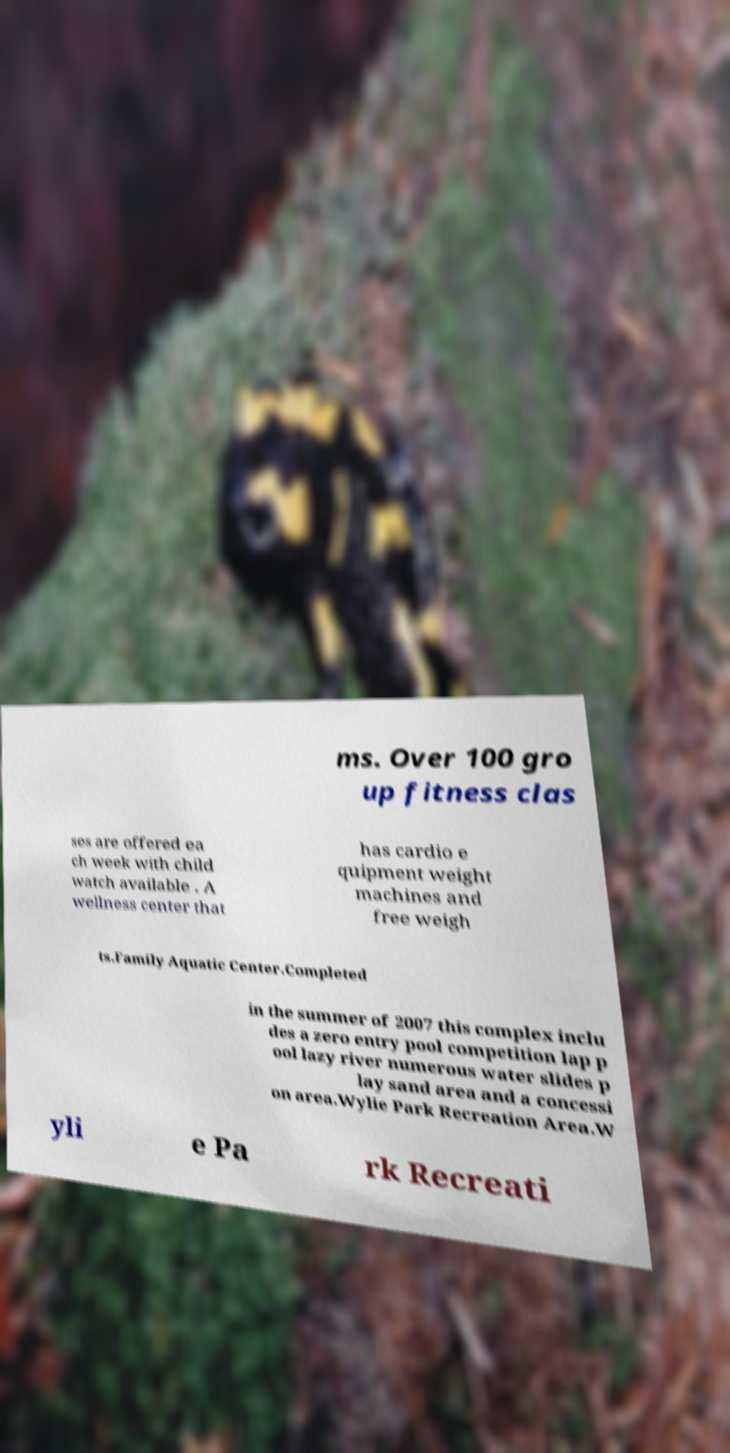There's text embedded in this image that I need extracted. Can you transcribe it verbatim? ms. Over 100 gro up fitness clas ses are offered ea ch week with child watch available . A wellness center that has cardio e quipment weight machines and free weigh ts.Family Aquatic Center.Completed in the summer of 2007 this complex inclu des a zero entry pool competition lap p ool lazy river numerous water slides p lay sand area and a concessi on area.Wylie Park Recreation Area.W yli e Pa rk Recreati 